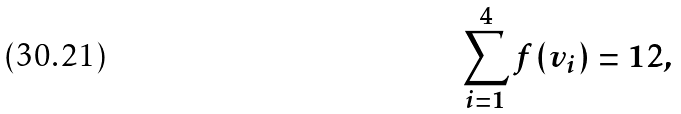<formula> <loc_0><loc_0><loc_500><loc_500>\sum _ { i = 1 } ^ { 4 } f ( v _ { i } ) = 1 2 ,</formula> 